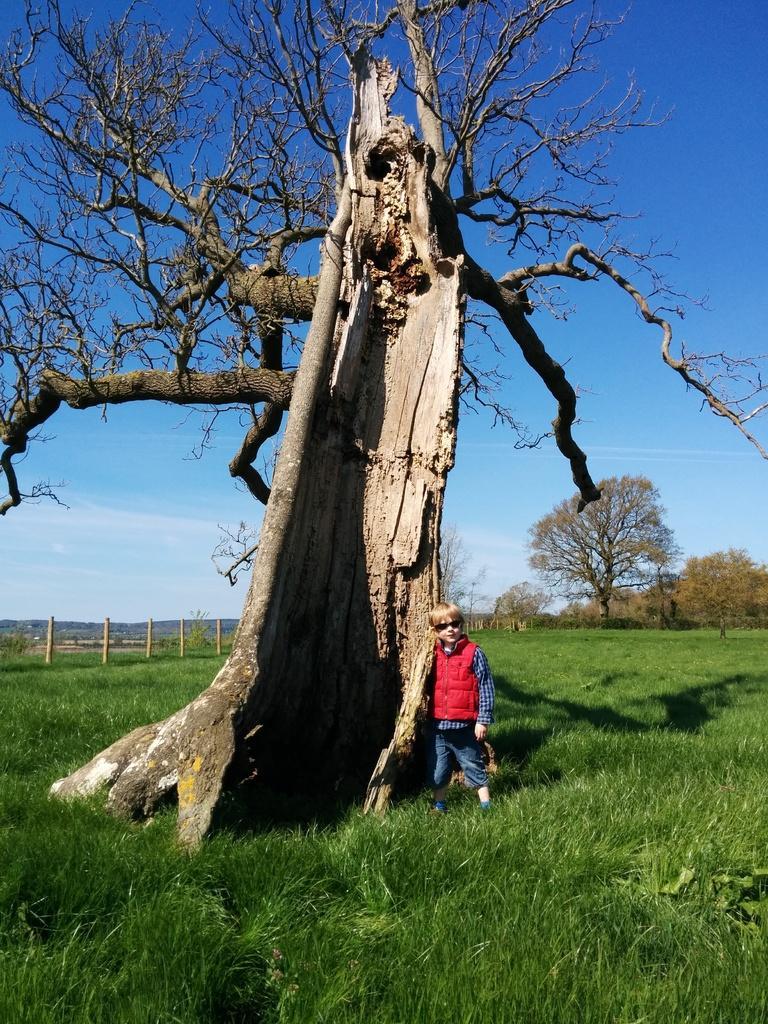How would you summarize this image in a sentence or two? In this image we can see a child wearing goggles standing beside the tree, there we can see few plants, trees and the grass, there we can see few stone pillars and some clouds in the sky. 